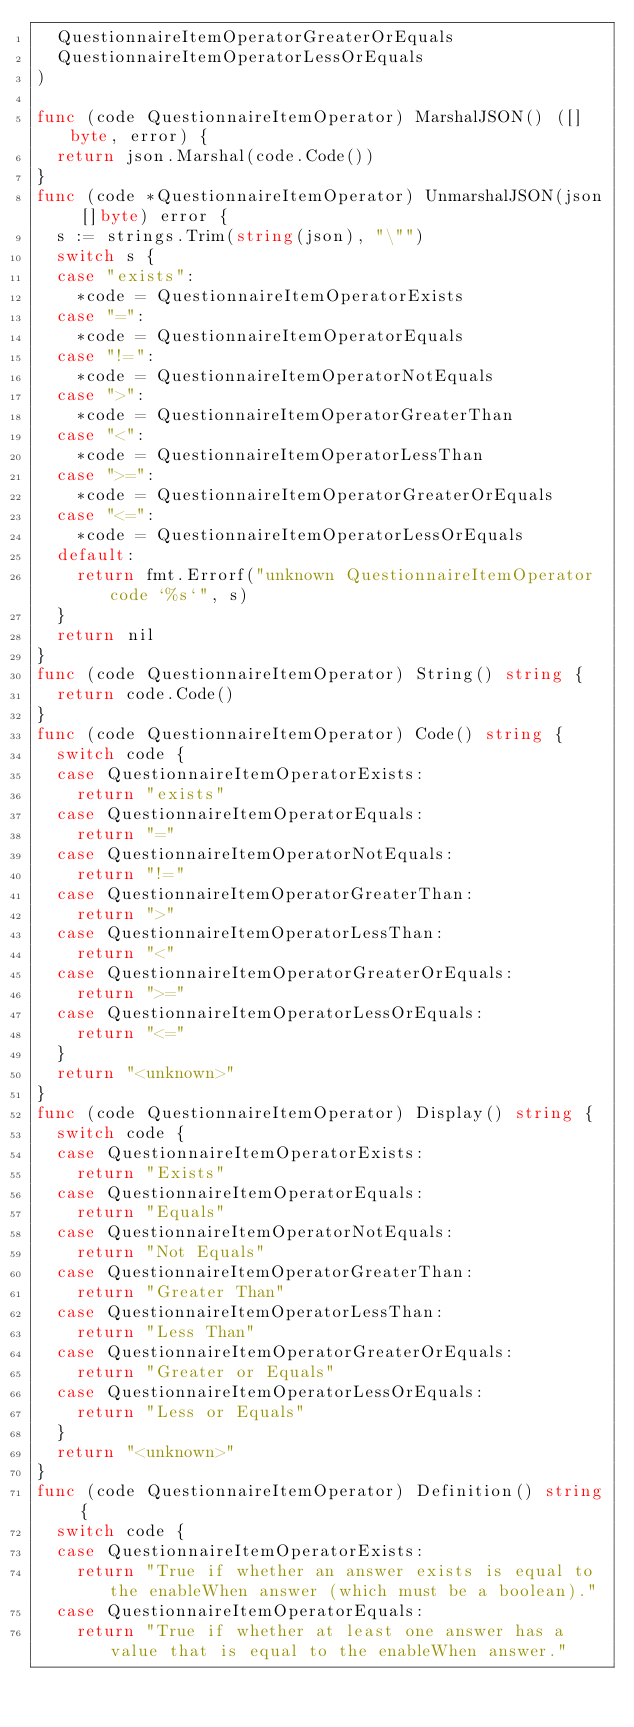<code> <loc_0><loc_0><loc_500><loc_500><_Go_>	QuestionnaireItemOperatorGreaterOrEquals
	QuestionnaireItemOperatorLessOrEquals
)

func (code QuestionnaireItemOperator) MarshalJSON() ([]byte, error) {
	return json.Marshal(code.Code())
}
func (code *QuestionnaireItemOperator) UnmarshalJSON(json []byte) error {
	s := strings.Trim(string(json), "\"")
	switch s {
	case "exists":
		*code = QuestionnaireItemOperatorExists
	case "=":
		*code = QuestionnaireItemOperatorEquals
	case "!=":
		*code = QuestionnaireItemOperatorNotEquals
	case ">":
		*code = QuestionnaireItemOperatorGreaterThan
	case "<":
		*code = QuestionnaireItemOperatorLessThan
	case ">=":
		*code = QuestionnaireItemOperatorGreaterOrEquals
	case "<=":
		*code = QuestionnaireItemOperatorLessOrEquals
	default:
		return fmt.Errorf("unknown QuestionnaireItemOperator code `%s`", s)
	}
	return nil
}
func (code QuestionnaireItemOperator) String() string {
	return code.Code()
}
func (code QuestionnaireItemOperator) Code() string {
	switch code {
	case QuestionnaireItemOperatorExists:
		return "exists"
	case QuestionnaireItemOperatorEquals:
		return "="
	case QuestionnaireItemOperatorNotEquals:
		return "!="
	case QuestionnaireItemOperatorGreaterThan:
		return ">"
	case QuestionnaireItemOperatorLessThan:
		return "<"
	case QuestionnaireItemOperatorGreaterOrEquals:
		return ">="
	case QuestionnaireItemOperatorLessOrEquals:
		return "<="
	}
	return "<unknown>"
}
func (code QuestionnaireItemOperator) Display() string {
	switch code {
	case QuestionnaireItemOperatorExists:
		return "Exists"
	case QuestionnaireItemOperatorEquals:
		return "Equals"
	case QuestionnaireItemOperatorNotEquals:
		return "Not Equals"
	case QuestionnaireItemOperatorGreaterThan:
		return "Greater Than"
	case QuestionnaireItemOperatorLessThan:
		return "Less Than"
	case QuestionnaireItemOperatorGreaterOrEquals:
		return "Greater or Equals"
	case QuestionnaireItemOperatorLessOrEquals:
		return "Less or Equals"
	}
	return "<unknown>"
}
func (code QuestionnaireItemOperator) Definition() string {
	switch code {
	case QuestionnaireItemOperatorExists:
		return "True if whether an answer exists is equal to the enableWhen answer (which must be a boolean)."
	case QuestionnaireItemOperatorEquals:
		return "True if whether at least one answer has a value that is equal to the enableWhen answer."</code> 